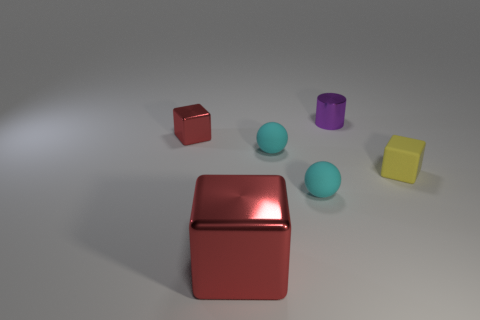Add 4 yellow things. How many objects exist? 10 Subtract all balls. How many objects are left? 4 Subtract all yellow blocks. Subtract all small gray matte spheres. How many objects are left? 5 Add 6 big metallic blocks. How many big metallic blocks are left? 7 Add 4 purple things. How many purple things exist? 5 Subtract 0 brown cubes. How many objects are left? 6 